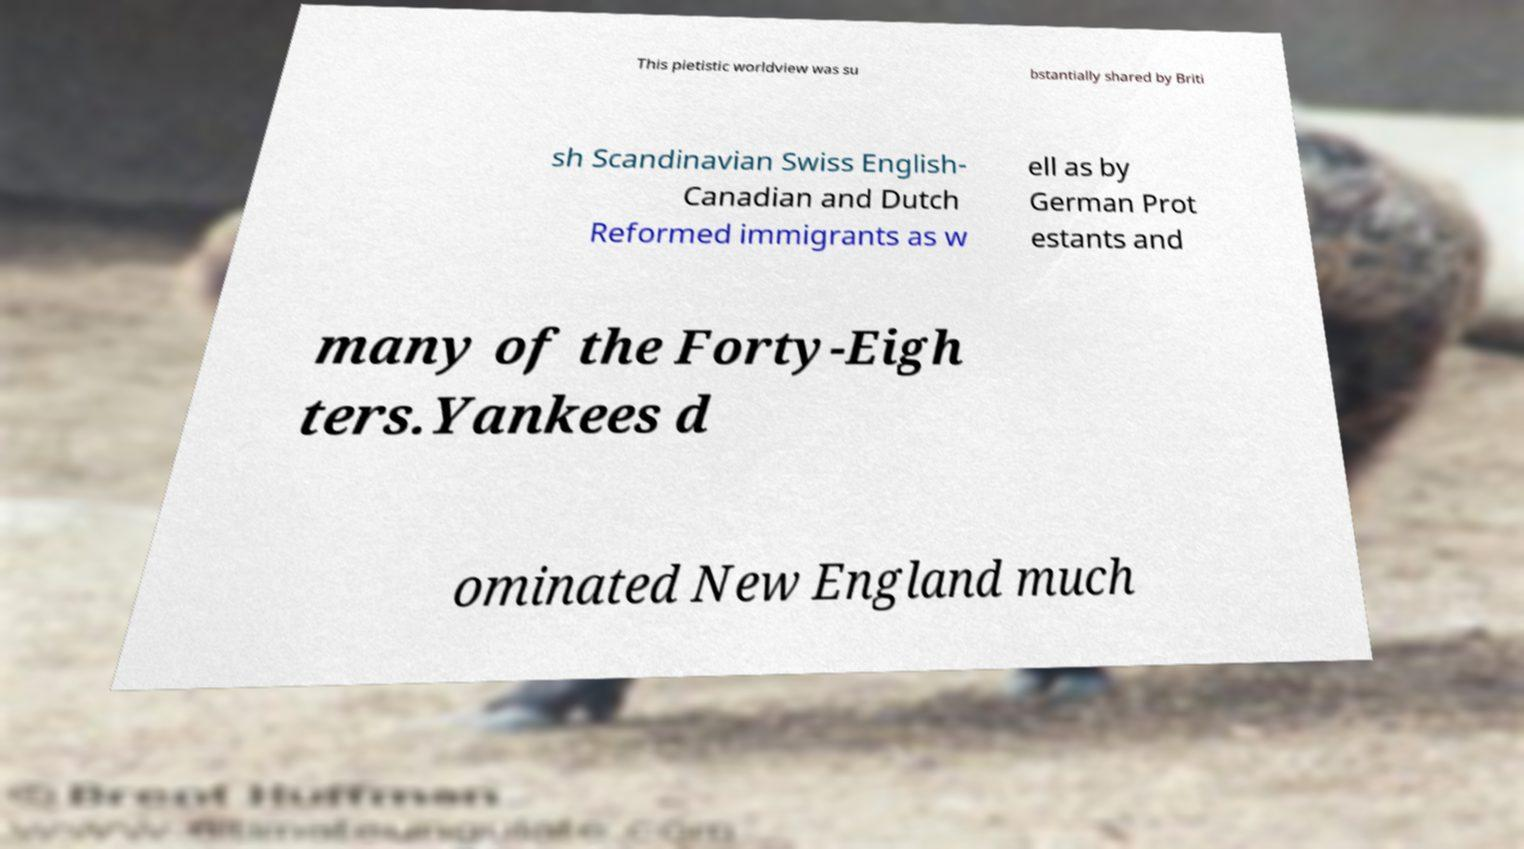What messages or text are displayed in this image? I need them in a readable, typed format. This pietistic worldview was su bstantially shared by Briti sh Scandinavian Swiss English- Canadian and Dutch Reformed immigrants as w ell as by German Prot estants and many of the Forty-Eigh ters.Yankees d ominated New England much 